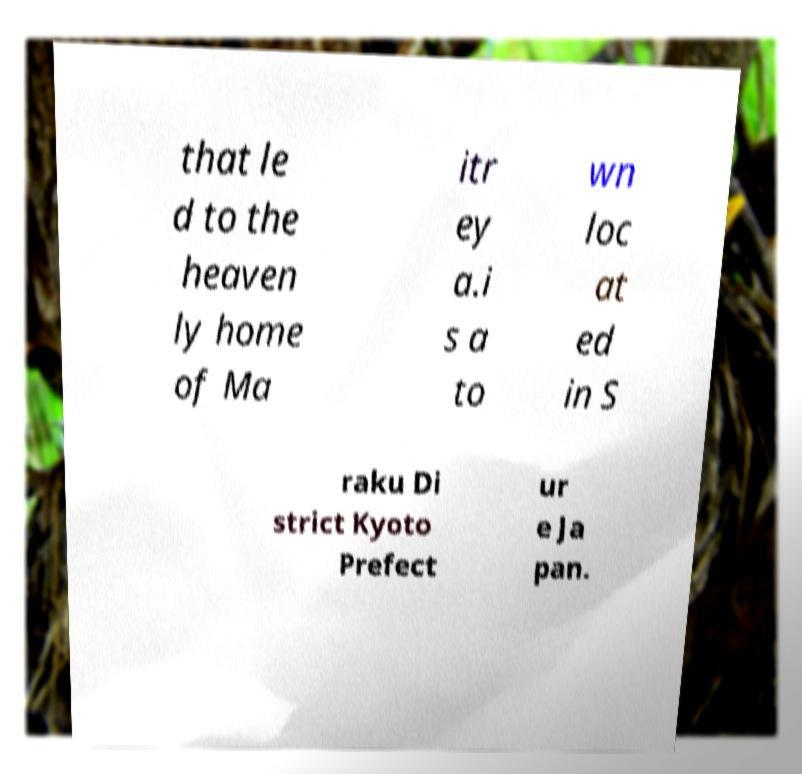Could you assist in decoding the text presented in this image and type it out clearly? that le d to the heaven ly home of Ma itr ey a.i s a to wn loc at ed in S raku Di strict Kyoto Prefect ur e Ja pan. 